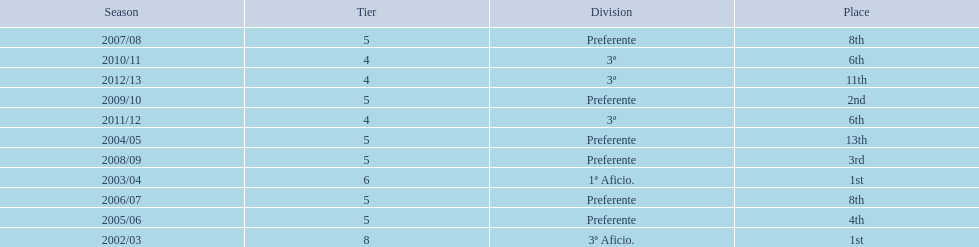Which seasons were played in tier four? 2010/11, 2011/12, 2012/13. Of these seasons, which resulted in 6th place? 2010/11, 2011/12. Which of the remaining happened last? 2011/12. 